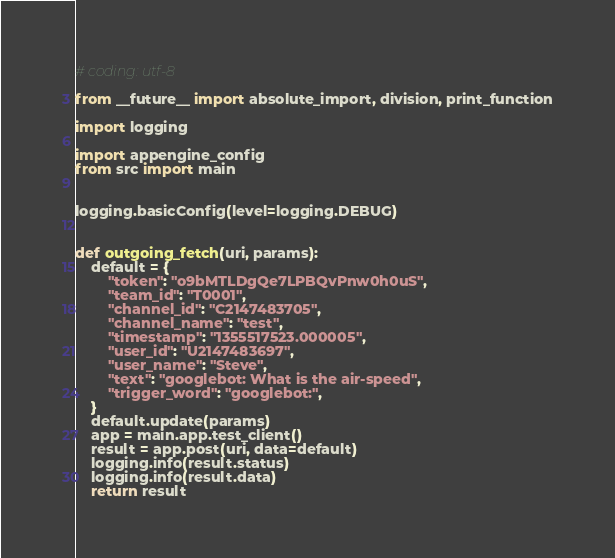Convert code to text. <code><loc_0><loc_0><loc_500><loc_500><_Python_># coding: utf-8

from __future__ import absolute_import, division, print_function

import logging 

import appengine_config
from src import main


logging.basicConfig(level=logging.DEBUG)


def outgoing_fetch(uri, params):
    default = {
        "token": "o9bMTLDgQe7LPBQvPnw0h0uS",
        "team_id": "T0001",
        "channel_id": "C2147483705",
        "channel_name": "test",
        "timestamp": "1355517523.000005",
        "user_id": "U2147483697",
        "user_name": "Steve",
        "text": "googlebot: What is the air-speed",
        "trigger_word": "googlebot:",
    }
    default.update(params)
    app = main.app.test_client()
    result = app.post(uri, data=default)
    logging.info(result.status)
    logging.info(result.data)
    return result
</code> 